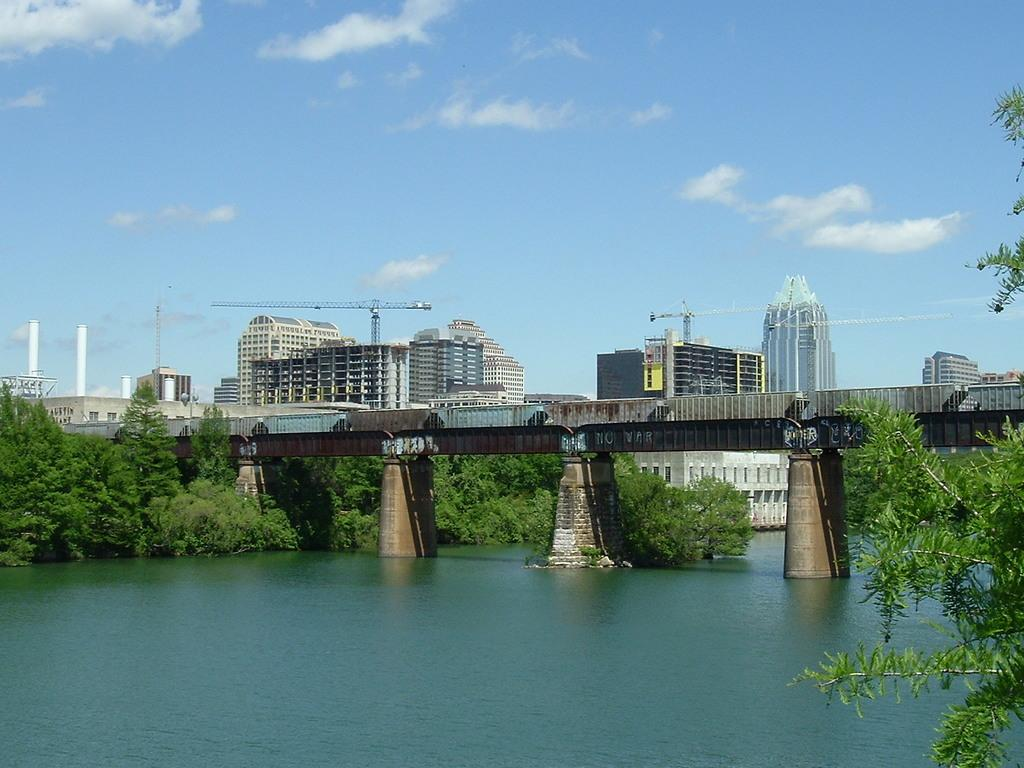What structure can be seen in the image? There is a bridge in the image. What type of vegetation is present in the image? There are trees in the image. What can be seen below the bridge? There is water visible below the bridge. What is visible in the background of the image? There are buildings and cranes in the background of the image. What is the color of the tongue of the person standing on the bridge? There is no person standing on the bridge in the image, and therefore no tongue to observe. 